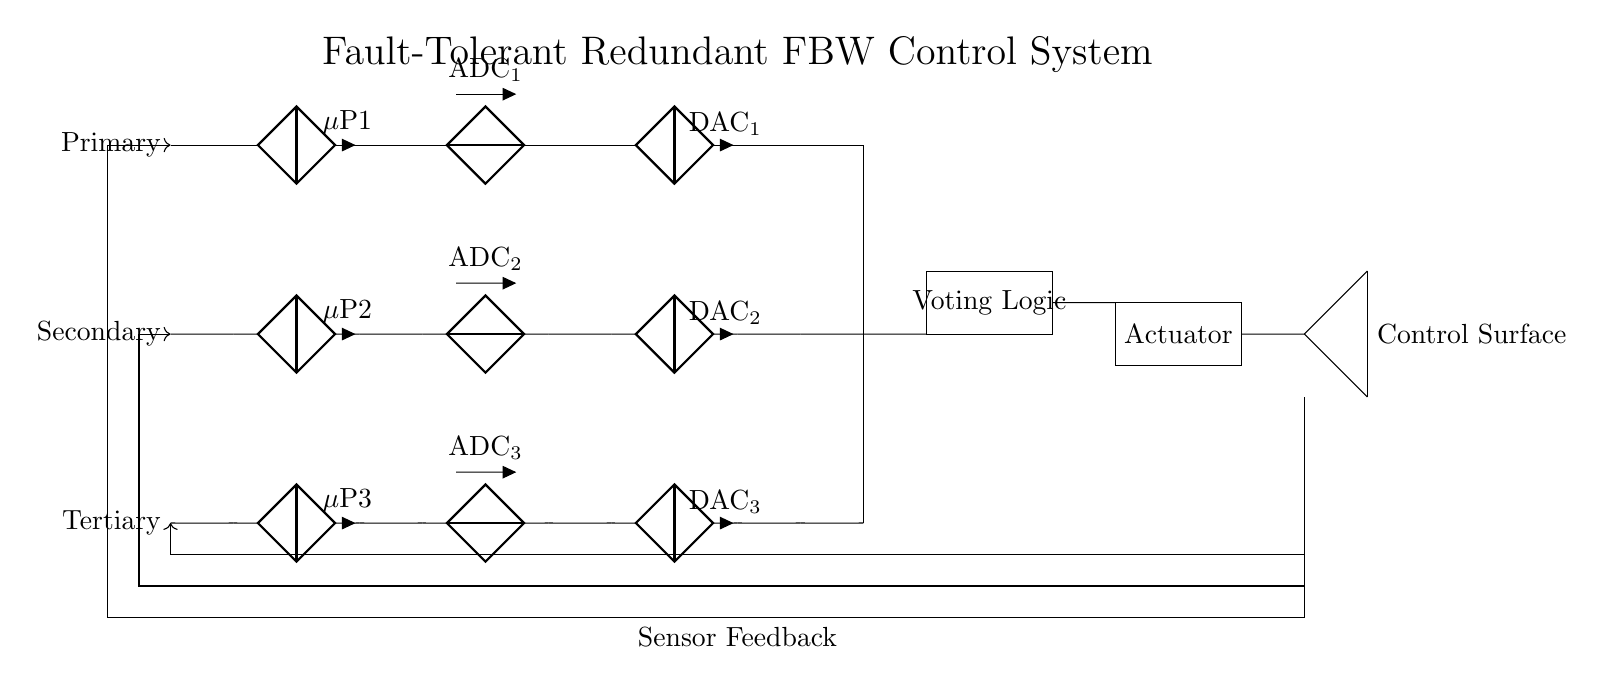What are the main components in this circuit? The main components are the microcontrollers, ADCs, DACs, voting logic, and actuator, which are essential for the control system's functionality.
Answer: microcontrollers, ADCs, DACs, voting logic, actuator How many control systems are featured in the circuit? There are three control systems: primary, secondary, and tertiary. Each system is designed to provide redundancy for fault tolerance.
Answer: three What is the purpose of the voting logic in the circuit? The voting logic consolidates the outputs from the three control systems to determine the most reliable signal for controlling the actuator. It enhances the reliability of the system by preventing erroneous outputs from affecting control.
Answer: consolidate outputs How is feedback provided to each control system? Feedback is provided through sensor feedback lines that route the sensor data back to each control system, allowing for real-time adjustments and corrections to the control surface movement.
Answer: sensor feedback lines What role does redundancy play in this circuit design? Redundancy ensures that if one control system fails, the others can continue to operate and maintain control of the aircraft, thereby enhancing safety and reliability in critical systems.
Answer: maintain control and safety What does the actuator do in this circuit? The actuator converts the electrical signal from the voting logic into mechanical movement to control the aircraft's control surfaces, directly impacting flight dynamics.
Answer: control surfaces Which components are responsible for analog-to-digital conversion? The components responsible for analog-to-digital conversion are the ADCs, which convert the analog signals from sensors into digital data for the microcontrollers to process.
Answer: ADCs 